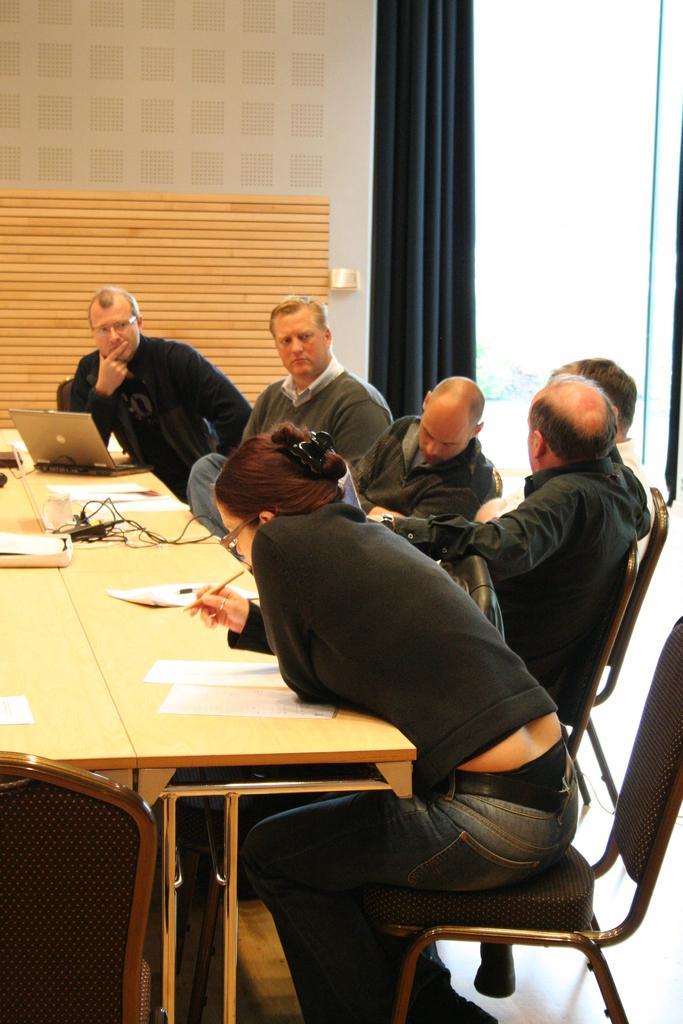How would you summarize this image in a sentence or two? In this picture we can see few persons sitting on the chair. This woman is holding a pen in her hand. on the table we can see a laptop and few papers. On the background we can see a wall in cream colour. This is a blue curtain. 